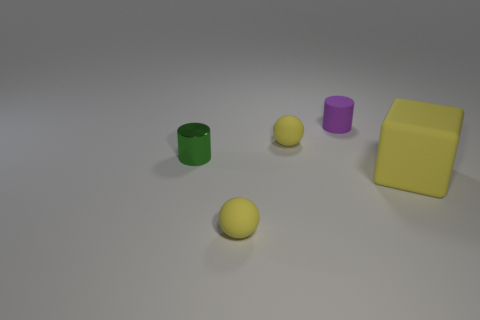Is there any other thing that is the same size as the yellow cube?
Your answer should be compact. No. Is there any other thing that has the same material as the green object?
Your response must be concise. No. What number of green things are either tiny cylinders or small metal cylinders?
Your answer should be compact. 1. What number of small rubber things are the same shape as the metal thing?
Make the answer very short. 1. How many rubber things are the same size as the yellow cube?
Your answer should be very brief. 0. What is the material of the tiny green thing that is the same shape as the small purple thing?
Your answer should be very brief. Metal. There is a small matte ball that is behind the big rubber cube; what is its color?
Provide a short and direct response. Yellow. Is the number of tiny yellow balls behind the big yellow thing greater than the number of things?
Make the answer very short. No. What color is the rubber cylinder?
Offer a very short reply. Purple. What is the shape of the yellow matte thing that is behind the big block that is in front of the ball behind the big object?
Your answer should be very brief. Sphere. 